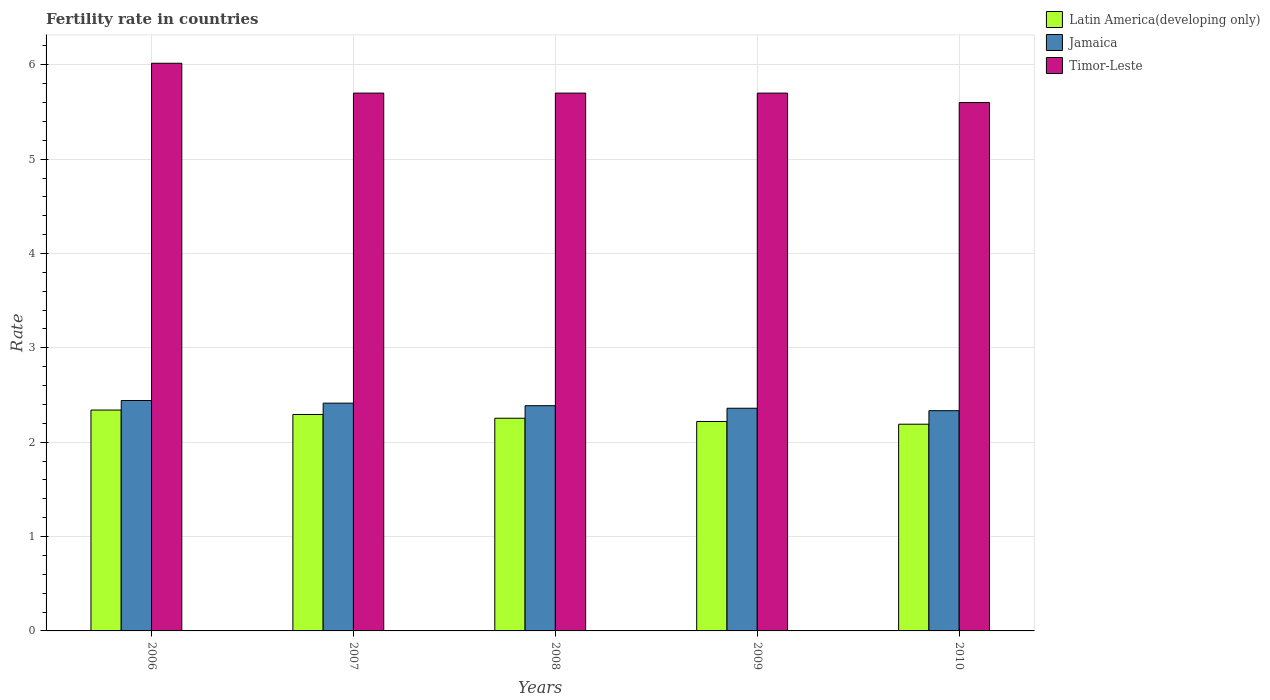How many different coloured bars are there?
Your answer should be compact. 3. How many groups of bars are there?
Make the answer very short. 5. Are the number of bars per tick equal to the number of legend labels?
Make the answer very short. Yes. Are the number of bars on each tick of the X-axis equal?
Your answer should be compact. Yes. How many bars are there on the 2nd tick from the left?
Provide a short and direct response. 3. How many bars are there on the 3rd tick from the right?
Your answer should be very brief. 3. What is the fertility rate in Latin America(developing only) in 2008?
Your response must be concise. 2.25. Across all years, what is the maximum fertility rate in Timor-Leste?
Offer a very short reply. 6.02. Across all years, what is the minimum fertility rate in Latin America(developing only)?
Your response must be concise. 2.19. In which year was the fertility rate in Timor-Leste minimum?
Give a very brief answer. 2010. What is the total fertility rate in Latin America(developing only) in the graph?
Your response must be concise. 11.3. What is the difference between the fertility rate in Timor-Leste in 2006 and that in 2007?
Your answer should be very brief. 0.32. What is the difference between the fertility rate in Timor-Leste in 2009 and the fertility rate in Jamaica in 2006?
Your response must be concise. 3.26. What is the average fertility rate in Timor-Leste per year?
Offer a terse response. 5.74. In the year 2006, what is the difference between the fertility rate in Latin America(developing only) and fertility rate in Timor-Leste?
Keep it short and to the point. -3.68. What is the ratio of the fertility rate in Timor-Leste in 2006 to that in 2008?
Offer a terse response. 1.06. Is the difference between the fertility rate in Latin America(developing only) in 2006 and 2008 greater than the difference between the fertility rate in Timor-Leste in 2006 and 2008?
Ensure brevity in your answer.  No. What is the difference between the highest and the second highest fertility rate in Jamaica?
Your answer should be very brief. 0.03. What is the difference between the highest and the lowest fertility rate in Jamaica?
Ensure brevity in your answer.  0.11. In how many years, is the fertility rate in Timor-Leste greater than the average fertility rate in Timor-Leste taken over all years?
Keep it short and to the point. 1. What does the 1st bar from the left in 2010 represents?
Make the answer very short. Latin America(developing only). What does the 3rd bar from the right in 2008 represents?
Offer a terse response. Latin America(developing only). Is it the case that in every year, the sum of the fertility rate in Jamaica and fertility rate in Latin America(developing only) is greater than the fertility rate in Timor-Leste?
Your answer should be very brief. No. How many bars are there?
Give a very brief answer. 15. Are all the bars in the graph horizontal?
Your answer should be compact. No. Are the values on the major ticks of Y-axis written in scientific E-notation?
Offer a terse response. No. Does the graph contain any zero values?
Make the answer very short. No. Where does the legend appear in the graph?
Your answer should be very brief. Top right. How many legend labels are there?
Ensure brevity in your answer.  3. What is the title of the graph?
Your answer should be very brief. Fertility rate in countries. Does "Yemen, Rep." appear as one of the legend labels in the graph?
Give a very brief answer. No. What is the label or title of the X-axis?
Offer a terse response. Years. What is the label or title of the Y-axis?
Ensure brevity in your answer.  Rate. What is the Rate in Latin America(developing only) in 2006?
Make the answer very short. 2.34. What is the Rate in Jamaica in 2006?
Provide a succinct answer. 2.44. What is the Rate of Timor-Leste in 2006?
Keep it short and to the point. 6.02. What is the Rate of Latin America(developing only) in 2007?
Keep it short and to the point. 2.29. What is the Rate in Jamaica in 2007?
Provide a succinct answer. 2.41. What is the Rate in Latin America(developing only) in 2008?
Your answer should be compact. 2.25. What is the Rate in Jamaica in 2008?
Make the answer very short. 2.39. What is the Rate of Latin America(developing only) in 2009?
Make the answer very short. 2.22. What is the Rate in Jamaica in 2009?
Provide a succinct answer. 2.36. What is the Rate of Timor-Leste in 2009?
Your response must be concise. 5.7. What is the Rate of Latin America(developing only) in 2010?
Give a very brief answer. 2.19. What is the Rate in Jamaica in 2010?
Provide a succinct answer. 2.33. Across all years, what is the maximum Rate of Latin America(developing only)?
Your answer should be compact. 2.34. Across all years, what is the maximum Rate of Jamaica?
Your response must be concise. 2.44. Across all years, what is the maximum Rate of Timor-Leste?
Make the answer very short. 6.02. Across all years, what is the minimum Rate in Latin America(developing only)?
Your response must be concise. 2.19. Across all years, what is the minimum Rate in Jamaica?
Offer a terse response. 2.33. What is the total Rate of Latin America(developing only) in the graph?
Make the answer very short. 11.3. What is the total Rate of Jamaica in the graph?
Your response must be concise. 11.94. What is the total Rate in Timor-Leste in the graph?
Your answer should be compact. 28.72. What is the difference between the Rate of Latin America(developing only) in 2006 and that in 2007?
Make the answer very short. 0.05. What is the difference between the Rate of Jamaica in 2006 and that in 2007?
Offer a very short reply. 0.03. What is the difference between the Rate of Timor-Leste in 2006 and that in 2007?
Provide a succinct answer. 0.32. What is the difference between the Rate of Latin America(developing only) in 2006 and that in 2008?
Your response must be concise. 0.09. What is the difference between the Rate in Jamaica in 2006 and that in 2008?
Ensure brevity in your answer.  0.06. What is the difference between the Rate in Timor-Leste in 2006 and that in 2008?
Make the answer very short. 0.32. What is the difference between the Rate in Latin America(developing only) in 2006 and that in 2009?
Make the answer very short. 0.12. What is the difference between the Rate of Jamaica in 2006 and that in 2009?
Your response must be concise. 0.08. What is the difference between the Rate of Timor-Leste in 2006 and that in 2009?
Ensure brevity in your answer.  0.32. What is the difference between the Rate in Latin America(developing only) in 2006 and that in 2010?
Your answer should be very brief. 0.15. What is the difference between the Rate in Jamaica in 2006 and that in 2010?
Make the answer very short. 0.11. What is the difference between the Rate in Timor-Leste in 2006 and that in 2010?
Offer a very short reply. 0.42. What is the difference between the Rate of Jamaica in 2007 and that in 2008?
Make the answer very short. 0.03. What is the difference between the Rate in Timor-Leste in 2007 and that in 2008?
Your answer should be very brief. 0. What is the difference between the Rate in Latin America(developing only) in 2007 and that in 2009?
Give a very brief answer. 0.07. What is the difference between the Rate of Jamaica in 2007 and that in 2009?
Your answer should be very brief. 0.05. What is the difference between the Rate in Latin America(developing only) in 2007 and that in 2010?
Your answer should be compact. 0.1. What is the difference between the Rate in Latin America(developing only) in 2008 and that in 2009?
Your response must be concise. 0.03. What is the difference between the Rate in Jamaica in 2008 and that in 2009?
Provide a succinct answer. 0.03. What is the difference between the Rate in Timor-Leste in 2008 and that in 2009?
Your answer should be compact. 0. What is the difference between the Rate in Latin America(developing only) in 2008 and that in 2010?
Offer a terse response. 0.06. What is the difference between the Rate of Jamaica in 2008 and that in 2010?
Provide a short and direct response. 0.05. What is the difference between the Rate of Timor-Leste in 2008 and that in 2010?
Give a very brief answer. 0.1. What is the difference between the Rate of Latin America(developing only) in 2009 and that in 2010?
Provide a short and direct response. 0.03. What is the difference between the Rate in Jamaica in 2009 and that in 2010?
Your answer should be very brief. 0.03. What is the difference between the Rate of Latin America(developing only) in 2006 and the Rate of Jamaica in 2007?
Offer a terse response. -0.07. What is the difference between the Rate of Latin America(developing only) in 2006 and the Rate of Timor-Leste in 2007?
Offer a terse response. -3.36. What is the difference between the Rate of Jamaica in 2006 and the Rate of Timor-Leste in 2007?
Provide a short and direct response. -3.26. What is the difference between the Rate of Latin America(developing only) in 2006 and the Rate of Jamaica in 2008?
Keep it short and to the point. -0.05. What is the difference between the Rate of Latin America(developing only) in 2006 and the Rate of Timor-Leste in 2008?
Make the answer very short. -3.36. What is the difference between the Rate in Jamaica in 2006 and the Rate in Timor-Leste in 2008?
Offer a terse response. -3.26. What is the difference between the Rate of Latin America(developing only) in 2006 and the Rate of Jamaica in 2009?
Your answer should be compact. -0.02. What is the difference between the Rate in Latin America(developing only) in 2006 and the Rate in Timor-Leste in 2009?
Provide a short and direct response. -3.36. What is the difference between the Rate in Jamaica in 2006 and the Rate in Timor-Leste in 2009?
Provide a short and direct response. -3.26. What is the difference between the Rate of Latin America(developing only) in 2006 and the Rate of Jamaica in 2010?
Ensure brevity in your answer.  0.01. What is the difference between the Rate in Latin America(developing only) in 2006 and the Rate in Timor-Leste in 2010?
Offer a very short reply. -3.26. What is the difference between the Rate in Jamaica in 2006 and the Rate in Timor-Leste in 2010?
Your answer should be very brief. -3.16. What is the difference between the Rate in Latin America(developing only) in 2007 and the Rate in Jamaica in 2008?
Provide a succinct answer. -0.09. What is the difference between the Rate in Latin America(developing only) in 2007 and the Rate in Timor-Leste in 2008?
Offer a terse response. -3.41. What is the difference between the Rate of Jamaica in 2007 and the Rate of Timor-Leste in 2008?
Your answer should be compact. -3.29. What is the difference between the Rate of Latin America(developing only) in 2007 and the Rate of Jamaica in 2009?
Offer a terse response. -0.07. What is the difference between the Rate of Latin America(developing only) in 2007 and the Rate of Timor-Leste in 2009?
Keep it short and to the point. -3.41. What is the difference between the Rate of Jamaica in 2007 and the Rate of Timor-Leste in 2009?
Your response must be concise. -3.29. What is the difference between the Rate of Latin America(developing only) in 2007 and the Rate of Jamaica in 2010?
Offer a terse response. -0.04. What is the difference between the Rate of Latin America(developing only) in 2007 and the Rate of Timor-Leste in 2010?
Give a very brief answer. -3.31. What is the difference between the Rate in Jamaica in 2007 and the Rate in Timor-Leste in 2010?
Keep it short and to the point. -3.19. What is the difference between the Rate in Latin America(developing only) in 2008 and the Rate in Jamaica in 2009?
Ensure brevity in your answer.  -0.11. What is the difference between the Rate in Latin America(developing only) in 2008 and the Rate in Timor-Leste in 2009?
Make the answer very short. -3.45. What is the difference between the Rate of Jamaica in 2008 and the Rate of Timor-Leste in 2009?
Your response must be concise. -3.31. What is the difference between the Rate of Latin America(developing only) in 2008 and the Rate of Jamaica in 2010?
Make the answer very short. -0.08. What is the difference between the Rate in Latin America(developing only) in 2008 and the Rate in Timor-Leste in 2010?
Your answer should be very brief. -3.35. What is the difference between the Rate of Jamaica in 2008 and the Rate of Timor-Leste in 2010?
Offer a very short reply. -3.21. What is the difference between the Rate in Latin America(developing only) in 2009 and the Rate in Jamaica in 2010?
Provide a short and direct response. -0.11. What is the difference between the Rate of Latin America(developing only) in 2009 and the Rate of Timor-Leste in 2010?
Your response must be concise. -3.38. What is the difference between the Rate of Jamaica in 2009 and the Rate of Timor-Leste in 2010?
Your answer should be very brief. -3.24. What is the average Rate in Latin America(developing only) per year?
Provide a succinct answer. 2.26. What is the average Rate in Jamaica per year?
Your answer should be compact. 2.39. What is the average Rate in Timor-Leste per year?
Ensure brevity in your answer.  5.74. In the year 2006, what is the difference between the Rate in Latin America(developing only) and Rate in Jamaica?
Your response must be concise. -0.1. In the year 2006, what is the difference between the Rate of Latin America(developing only) and Rate of Timor-Leste?
Ensure brevity in your answer.  -3.68. In the year 2006, what is the difference between the Rate of Jamaica and Rate of Timor-Leste?
Offer a terse response. -3.57. In the year 2007, what is the difference between the Rate of Latin America(developing only) and Rate of Jamaica?
Offer a very short reply. -0.12. In the year 2007, what is the difference between the Rate of Latin America(developing only) and Rate of Timor-Leste?
Your answer should be compact. -3.41. In the year 2007, what is the difference between the Rate of Jamaica and Rate of Timor-Leste?
Offer a very short reply. -3.29. In the year 2008, what is the difference between the Rate in Latin America(developing only) and Rate in Jamaica?
Your answer should be compact. -0.13. In the year 2008, what is the difference between the Rate in Latin America(developing only) and Rate in Timor-Leste?
Offer a terse response. -3.45. In the year 2008, what is the difference between the Rate of Jamaica and Rate of Timor-Leste?
Offer a terse response. -3.31. In the year 2009, what is the difference between the Rate in Latin America(developing only) and Rate in Jamaica?
Your answer should be compact. -0.14. In the year 2009, what is the difference between the Rate of Latin America(developing only) and Rate of Timor-Leste?
Your answer should be very brief. -3.48. In the year 2009, what is the difference between the Rate of Jamaica and Rate of Timor-Leste?
Ensure brevity in your answer.  -3.34. In the year 2010, what is the difference between the Rate in Latin America(developing only) and Rate in Jamaica?
Your answer should be very brief. -0.14. In the year 2010, what is the difference between the Rate in Latin America(developing only) and Rate in Timor-Leste?
Provide a succinct answer. -3.41. In the year 2010, what is the difference between the Rate of Jamaica and Rate of Timor-Leste?
Offer a very short reply. -3.27. What is the ratio of the Rate of Latin America(developing only) in 2006 to that in 2007?
Your answer should be compact. 1.02. What is the ratio of the Rate in Jamaica in 2006 to that in 2007?
Keep it short and to the point. 1.01. What is the ratio of the Rate in Timor-Leste in 2006 to that in 2007?
Give a very brief answer. 1.06. What is the ratio of the Rate in Latin America(developing only) in 2006 to that in 2008?
Offer a very short reply. 1.04. What is the ratio of the Rate in Jamaica in 2006 to that in 2008?
Ensure brevity in your answer.  1.02. What is the ratio of the Rate in Timor-Leste in 2006 to that in 2008?
Your answer should be very brief. 1.06. What is the ratio of the Rate of Latin America(developing only) in 2006 to that in 2009?
Give a very brief answer. 1.05. What is the ratio of the Rate in Jamaica in 2006 to that in 2009?
Offer a terse response. 1.03. What is the ratio of the Rate in Timor-Leste in 2006 to that in 2009?
Give a very brief answer. 1.06. What is the ratio of the Rate of Latin America(developing only) in 2006 to that in 2010?
Ensure brevity in your answer.  1.07. What is the ratio of the Rate of Jamaica in 2006 to that in 2010?
Provide a short and direct response. 1.05. What is the ratio of the Rate in Timor-Leste in 2006 to that in 2010?
Provide a short and direct response. 1.07. What is the ratio of the Rate in Latin America(developing only) in 2007 to that in 2008?
Provide a short and direct response. 1.02. What is the ratio of the Rate of Jamaica in 2007 to that in 2008?
Provide a succinct answer. 1.01. What is the ratio of the Rate of Timor-Leste in 2007 to that in 2008?
Keep it short and to the point. 1. What is the ratio of the Rate in Latin America(developing only) in 2007 to that in 2009?
Offer a terse response. 1.03. What is the ratio of the Rate of Jamaica in 2007 to that in 2009?
Your answer should be very brief. 1.02. What is the ratio of the Rate of Timor-Leste in 2007 to that in 2009?
Give a very brief answer. 1. What is the ratio of the Rate in Latin America(developing only) in 2007 to that in 2010?
Make the answer very short. 1.05. What is the ratio of the Rate in Jamaica in 2007 to that in 2010?
Ensure brevity in your answer.  1.03. What is the ratio of the Rate in Timor-Leste in 2007 to that in 2010?
Keep it short and to the point. 1.02. What is the ratio of the Rate in Latin America(developing only) in 2008 to that in 2009?
Offer a terse response. 1.02. What is the ratio of the Rate in Jamaica in 2008 to that in 2009?
Your answer should be very brief. 1.01. What is the ratio of the Rate of Latin America(developing only) in 2008 to that in 2010?
Your response must be concise. 1.03. What is the ratio of the Rate in Jamaica in 2008 to that in 2010?
Ensure brevity in your answer.  1.02. What is the ratio of the Rate of Timor-Leste in 2008 to that in 2010?
Provide a succinct answer. 1.02. What is the ratio of the Rate in Latin America(developing only) in 2009 to that in 2010?
Provide a short and direct response. 1.01. What is the ratio of the Rate of Jamaica in 2009 to that in 2010?
Make the answer very short. 1.01. What is the ratio of the Rate of Timor-Leste in 2009 to that in 2010?
Make the answer very short. 1.02. What is the difference between the highest and the second highest Rate in Latin America(developing only)?
Give a very brief answer. 0.05. What is the difference between the highest and the second highest Rate of Jamaica?
Ensure brevity in your answer.  0.03. What is the difference between the highest and the second highest Rate of Timor-Leste?
Provide a short and direct response. 0.32. What is the difference between the highest and the lowest Rate in Latin America(developing only)?
Offer a terse response. 0.15. What is the difference between the highest and the lowest Rate in Jamaica?
Offer a very short reply. 0.11. What is the difference between the highest and the lowest Rate in Timor-Leste?
Provide a succinct answer. 0.42. 